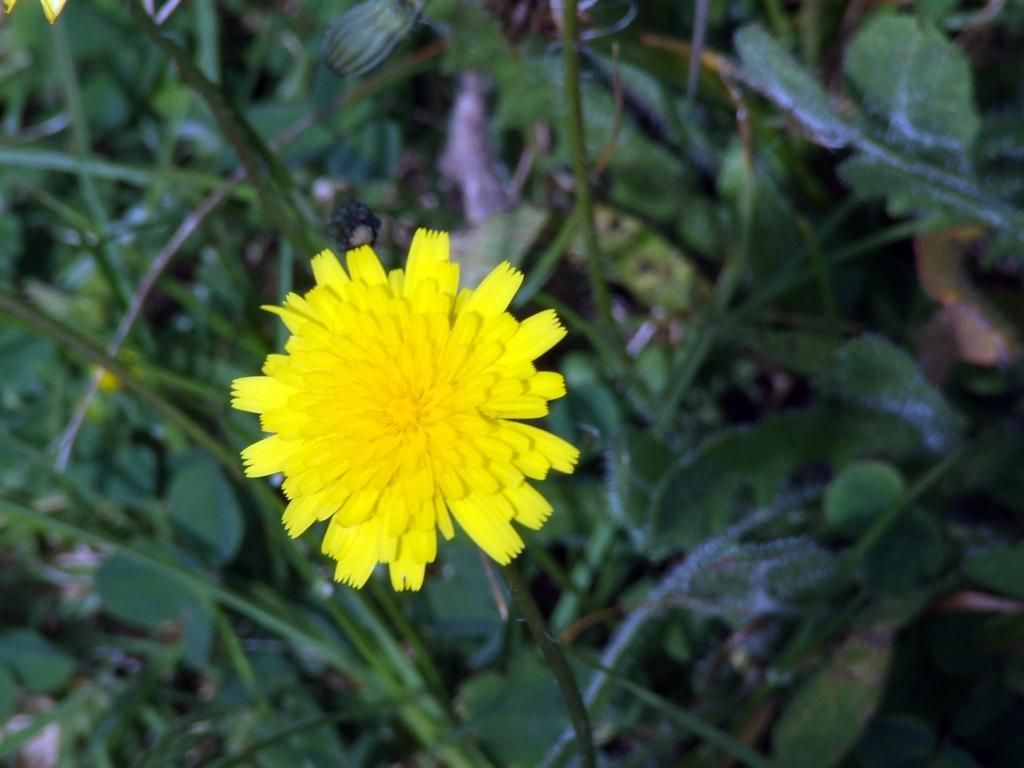What is the main subject in the center of the image? There is a flower in the center of the image. What can be seen in the background of the image? There are plants in the background of the image. What type of toothpaste is being used to water the plants in the image? There is no toothpaste present in the image, and toothpaste is not used for watering plants. 